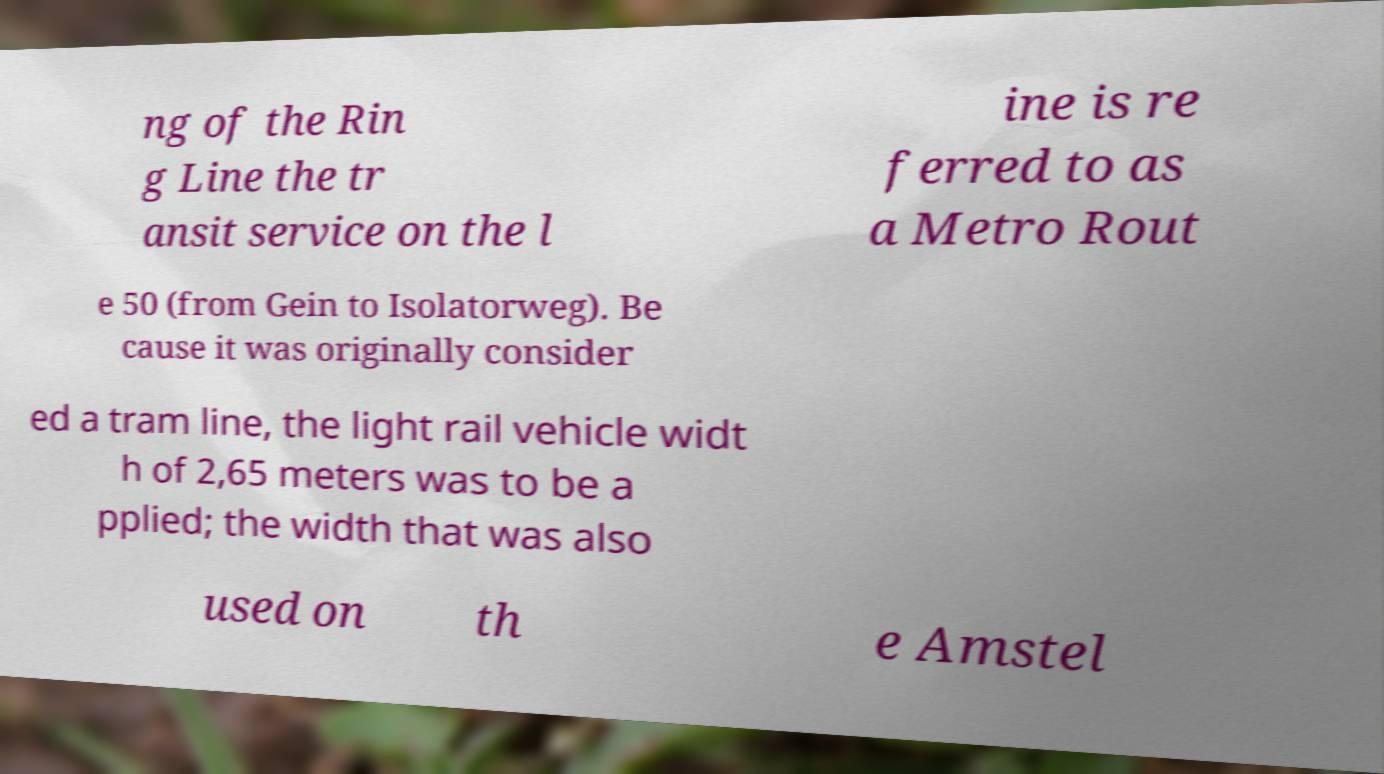Can you read and provide the text displayed in the image?This photo seems to have some interesting text. Can you extract and type it out for me? ng of the Rin g Line the tr ansit service on the l ine is re ferred to as a Metro Rout e 50 (from Gein to Isolatorweg). Be cause it was originally consider ed a tram line, the light rail vehicle widt h of 2,65 meters was to be a pplied; the width that was also used on th e Amstel 